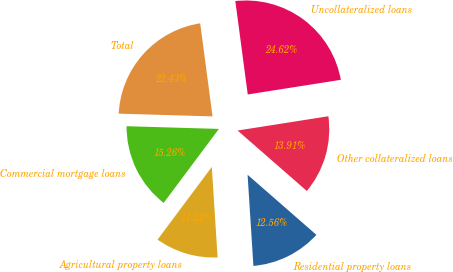Convert chart. <chart><loc_0><loc_0><loc_500><loc_500><pie_chart><fcel>Commercial mortgage loans<fcel>Agricultural property loans<fcel>Residential property loans<fcel>Other collateralized loans<fcel>Uncollateralized loans<fcel>Total<nl><fcel>15.26%<fcel>11.22%<fcel>12.56%<fcel>13.91%<fcel>24.62%<fcel>22.43%<nl></chart> 